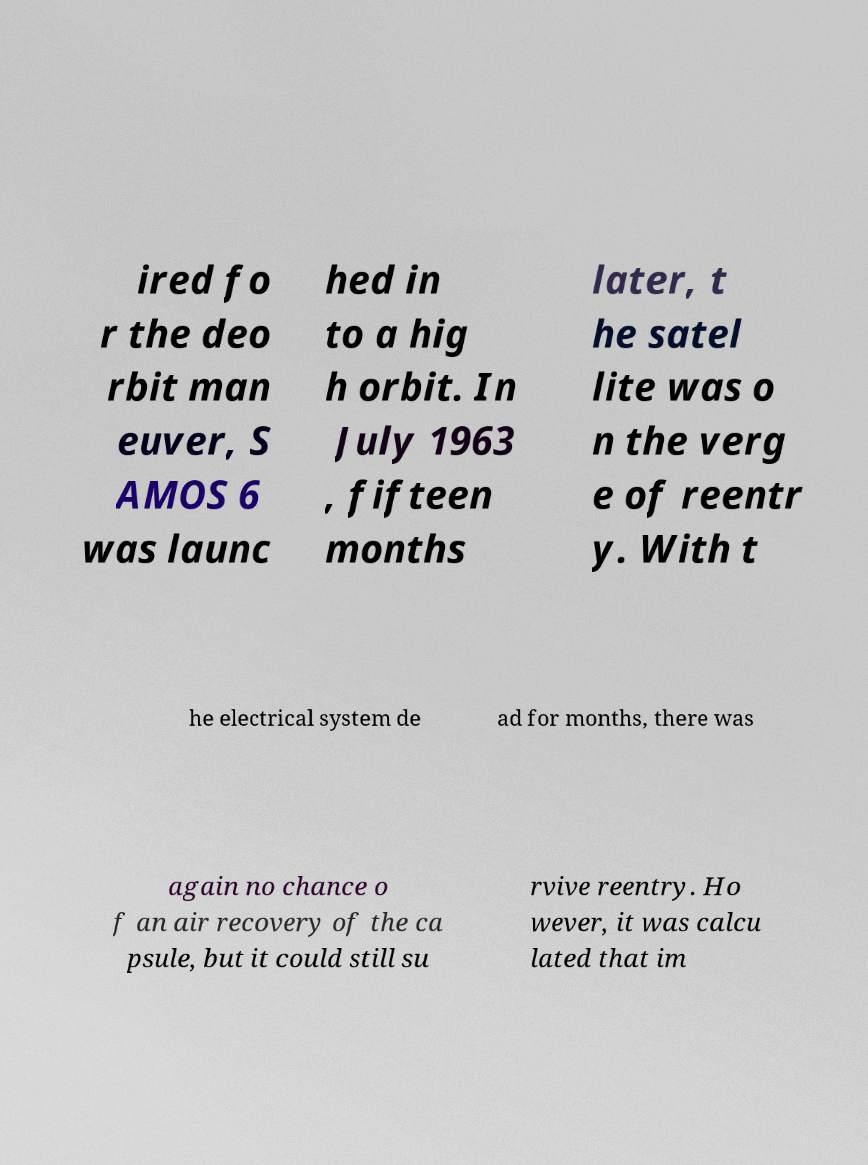What messages or text are displayed in this image? I need them in a readable, typed format. ired fo r the deo rbit man euver, S AMOS 6 was launc hed in to a hig h orbit. In July 1963 , fifteen months later, t he satel lite was o n the verg e of reentr y. With t he electrical system de ad for months, there was again no chance o f an air recovery of the ca psule, but it could still su rvive reentry. Ho wever, it was calcu lated that im 